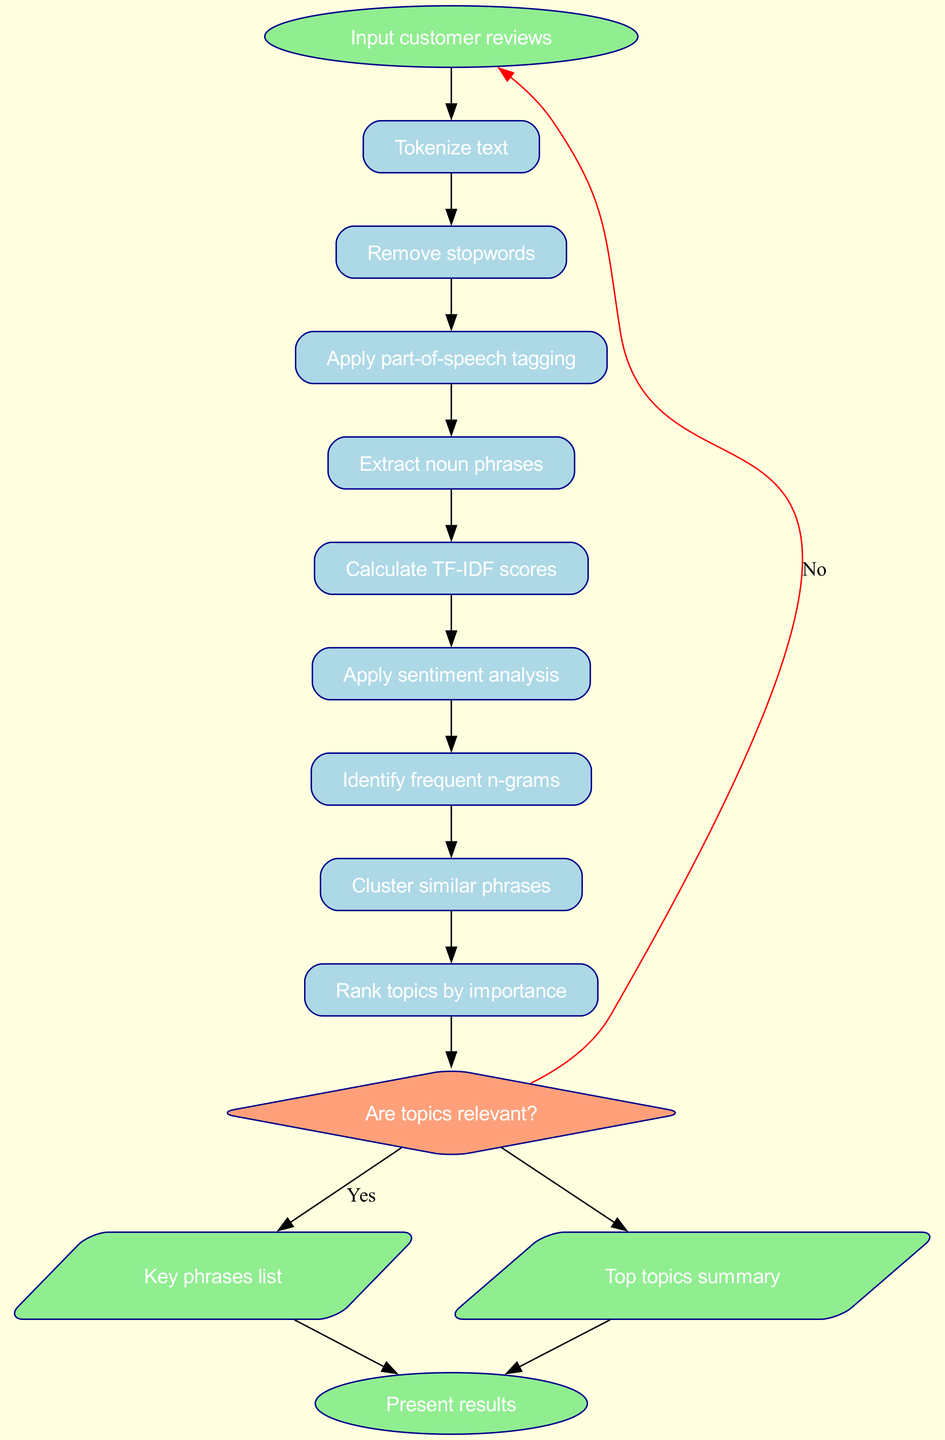What is the first step in the process? The diagram starts with the "Input customer reviews" node. This indicates that the first step is to take in customer reviews for analysis.
Answer: Input customer reviews How many steps are there in the process? The diagram contains a total of 9 steps listed in the process, leading to the decision point. Each step involves a specific action to analyze the reviews.
Answer: 9 What shape represents the decision point? The decision point is represented by a diamond shape in the diagram. This shape is commonly used in flowcharts to indicate a point where a decision is made.
Answer: Diamond Which process follows "Extract noun phrases"? After "Extract noun phrases", the next process is "Calculate TF-IDF scores". This indicates a sequence of operations that builds on the previous step.
Answer: Calculate TF-IDF scores What happens if the topics are not relevant? If the topics are not relevant, the flowchart indicates a red edge looping back to the start. This suggests that the process will begin again from "Input customer reviews".
Answer: Input customer reviews Which output is labeled as "Key phrases list"? The first output listed after the decision point is "Key phrases list", indicating that this is one of the main results of the analysis.
Answer: Key phrases list How many outputs are there in total? The diagram shows 2 outputs stemming from the decision point, which are the key phrases list and the top topics summary.
Answer: 2 What are the colors of the steps in the process? The steps in the process are filled with light blue color, as shown visually in the diagram, which is used to differentiate them from other node types.
Answer: Light blue Which process directly precedes the sentiment analysis step? The process that directly precedes "Apply sentiment analysis" is "Calculate TF-IDF scores", indicating the flow of the analysis leading into sentiment evaluation.
Answer: Calculate TF-IDF scores 